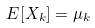Convert formula to latex. <formula><loc_0><loc_0><loc_500><loc_500>E [ X _ { k } ] = \mu _ { k }</formula> 